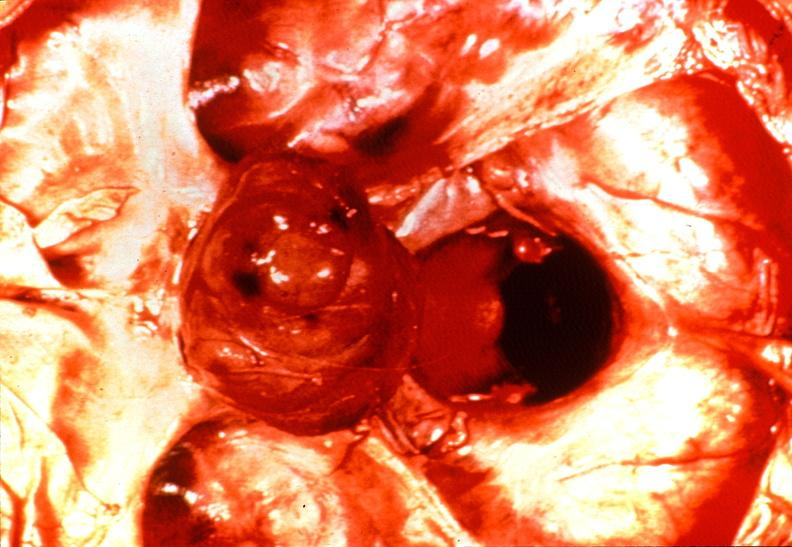where does this belong to?
Answer the question using a single word or phrase. Endocrine system 